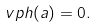<formula> <loc_0><loc_0><loc_500><loc_500>\ v p h ( a ) = 0 .</formula> 